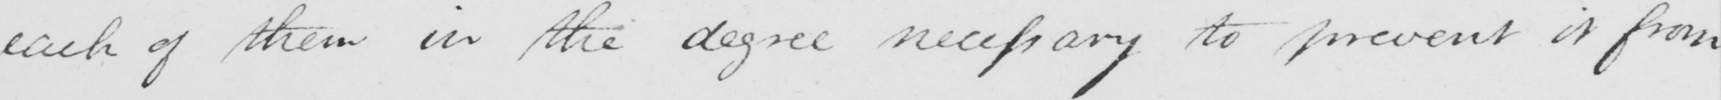Please provide the text content of this handwritten line. each of them in the degree necessary to prevent it from 